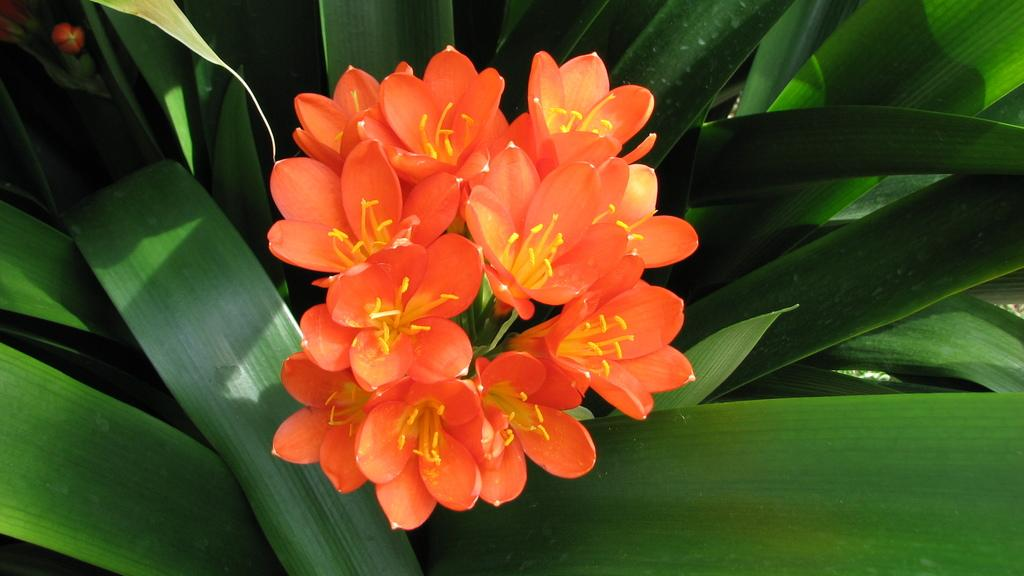What types of living organisms can be seen in the image? Flowers and plants are visible in the image. Can you describe the plants in the image? The plants in the image are not specified, but they are likely green and leafy. What might be the purpose of the flowers in the image? The purpose of the flowers in the image is not clear, but they could be for decoration or to attract pollinators. What color is the sock on the bed in the image? There is no bed or sock present in the image; it only contains flowers and plants. 